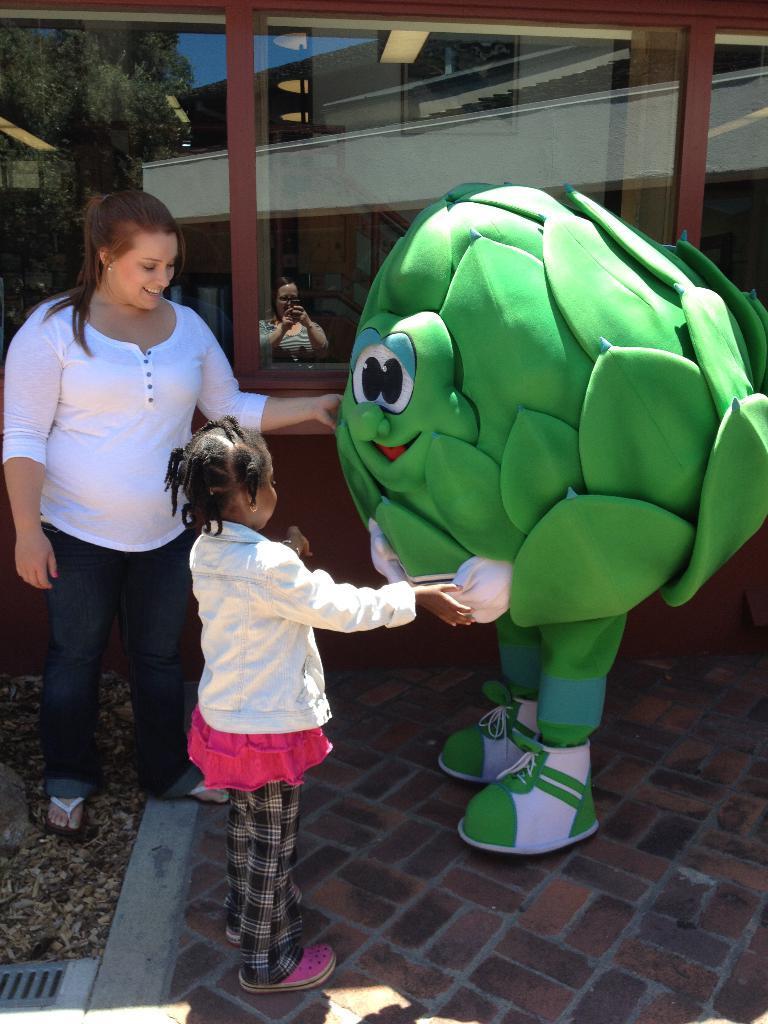Can you describe this image briefly? In the image there is a lady and a girl. They are standing. In front of them there is a person with a costume and he is standing. Behind them there is a glass wall. On the glass there is reflection of trees, buildings and also there is a person. 